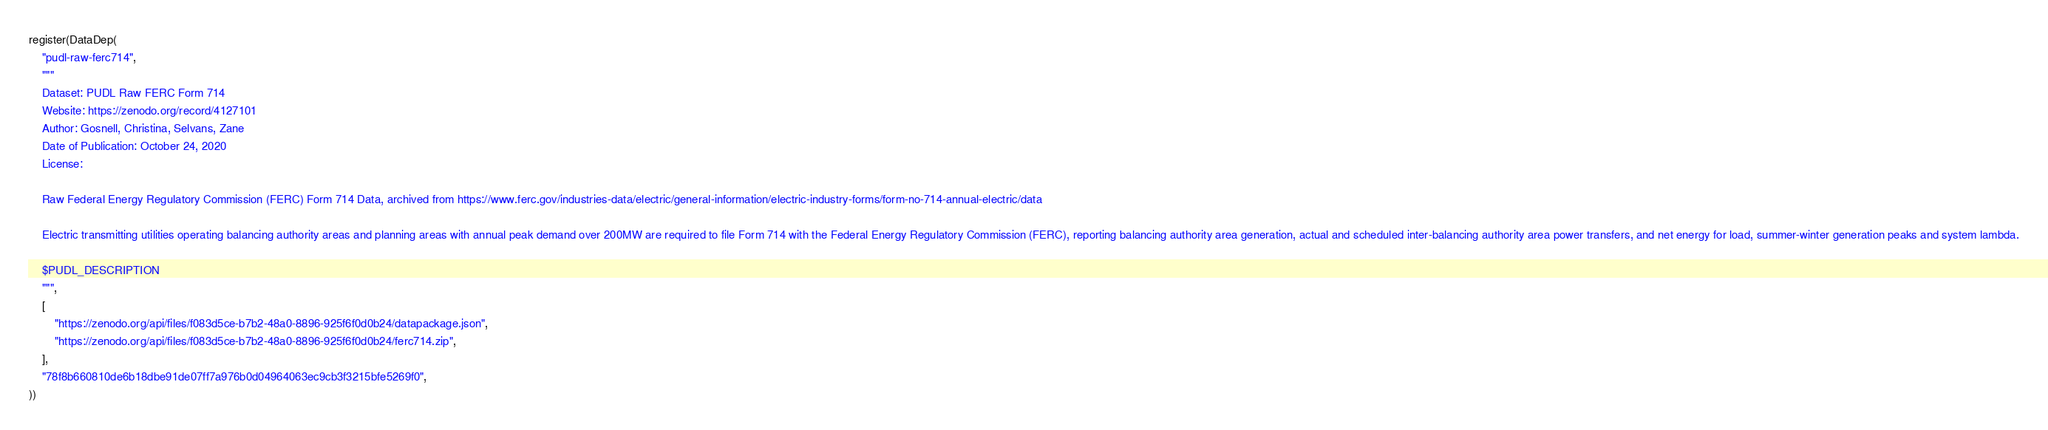<code> <loc_0><loc_0><loc_500><loc_500><_Julia_>register(DataDep(
    "pudl-raw-ferc714",
    """
    Dataset: PUDL Raw FERC Form 714
    Website: https://zenodo.org/record/4127101
    Author: Gosnell, Christina, Selvans, Zane
    Date of Publication: October 24, 2020
    License:

    Raw Federal Energy Regulatory Commission (FERC) Form 714 Data, archived from https://www.ferc.gov/industries-data/electric/general-information/electric-industry-forms/form-no-714-annual-electric/data

    Electric transmitting utilities operating balancing authority areas and planning areas with annual peak demand over 200MW are required to file Form 714 with the Federal Energy Regulatory Commission (FERC), reporting balancing authority area generation, actual and scheduled inter-balancing authority area power transfers, and net energy for load, summer-winter generation peaks and system lambda.

    $PUDL_DESCRIPTION
    """,
    [
        "https://zenodo.org/api/files/f083d5ce-b7b2-48a0-8896-925f6f0d0b24/datapackage.json",
        "https://zenodo.org/api/files/f083d5ce-b7b2-48a0-8896-925f6f0d0b24/ferc714.zip",
    ],
    "78f8b660810de6b18dbe91de07ff7a976b0d04964063ec9cb3f3215bfe5269f0",
))
</code> 